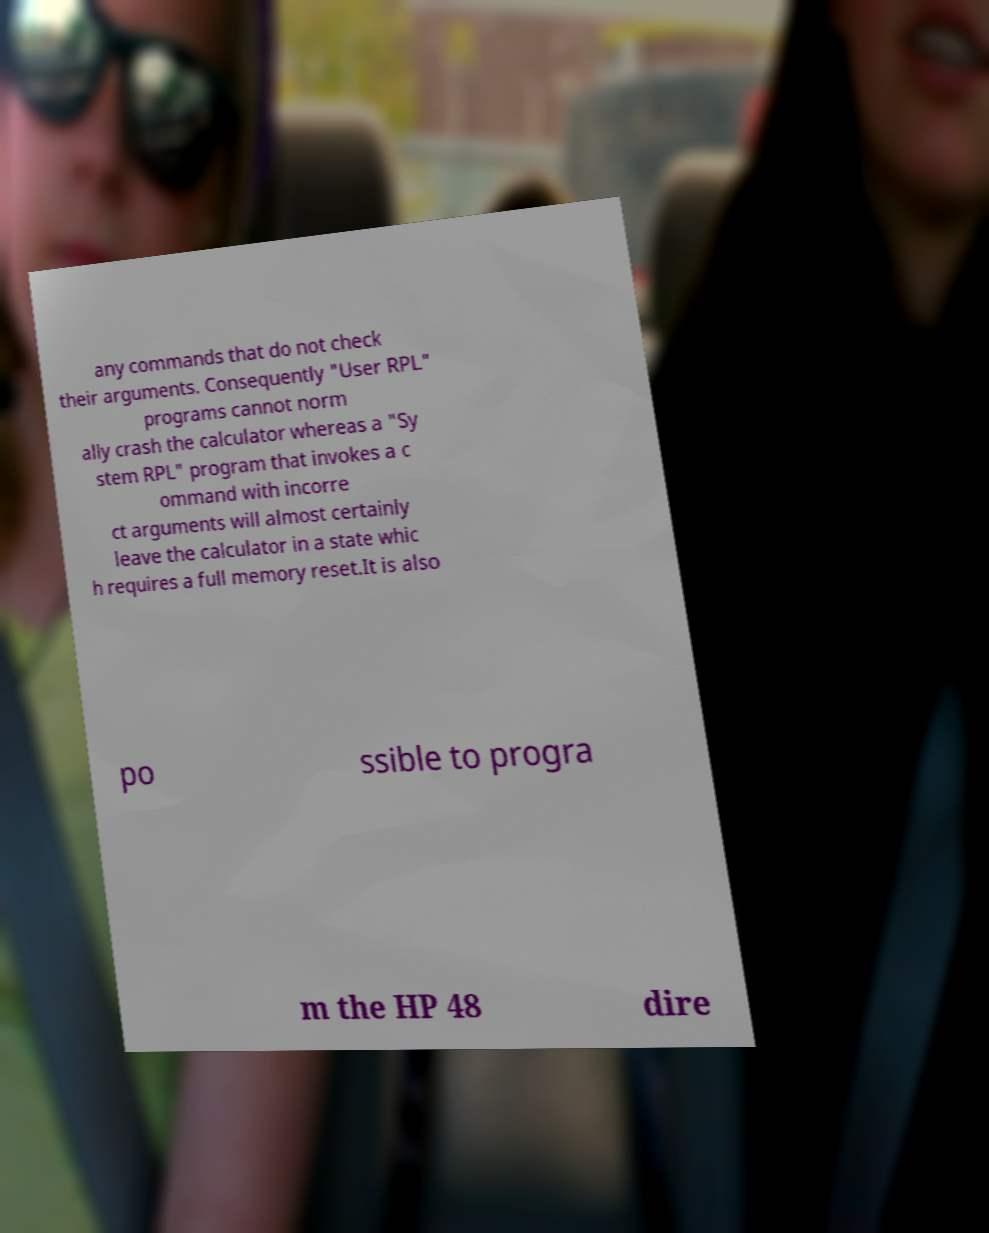Please identify and transcribe the text found in this image. any commands that do not check their arguments. Consequently "User RPL" programs cannot norm ally crash the calculator whereas a "Sy stem RPL" program that invokes a c ommand with incorre ct arguments will almost certainly leave the calculator in a state whic h requires a full memory reset.It is also po ssible to progra m the HP 48 dire 